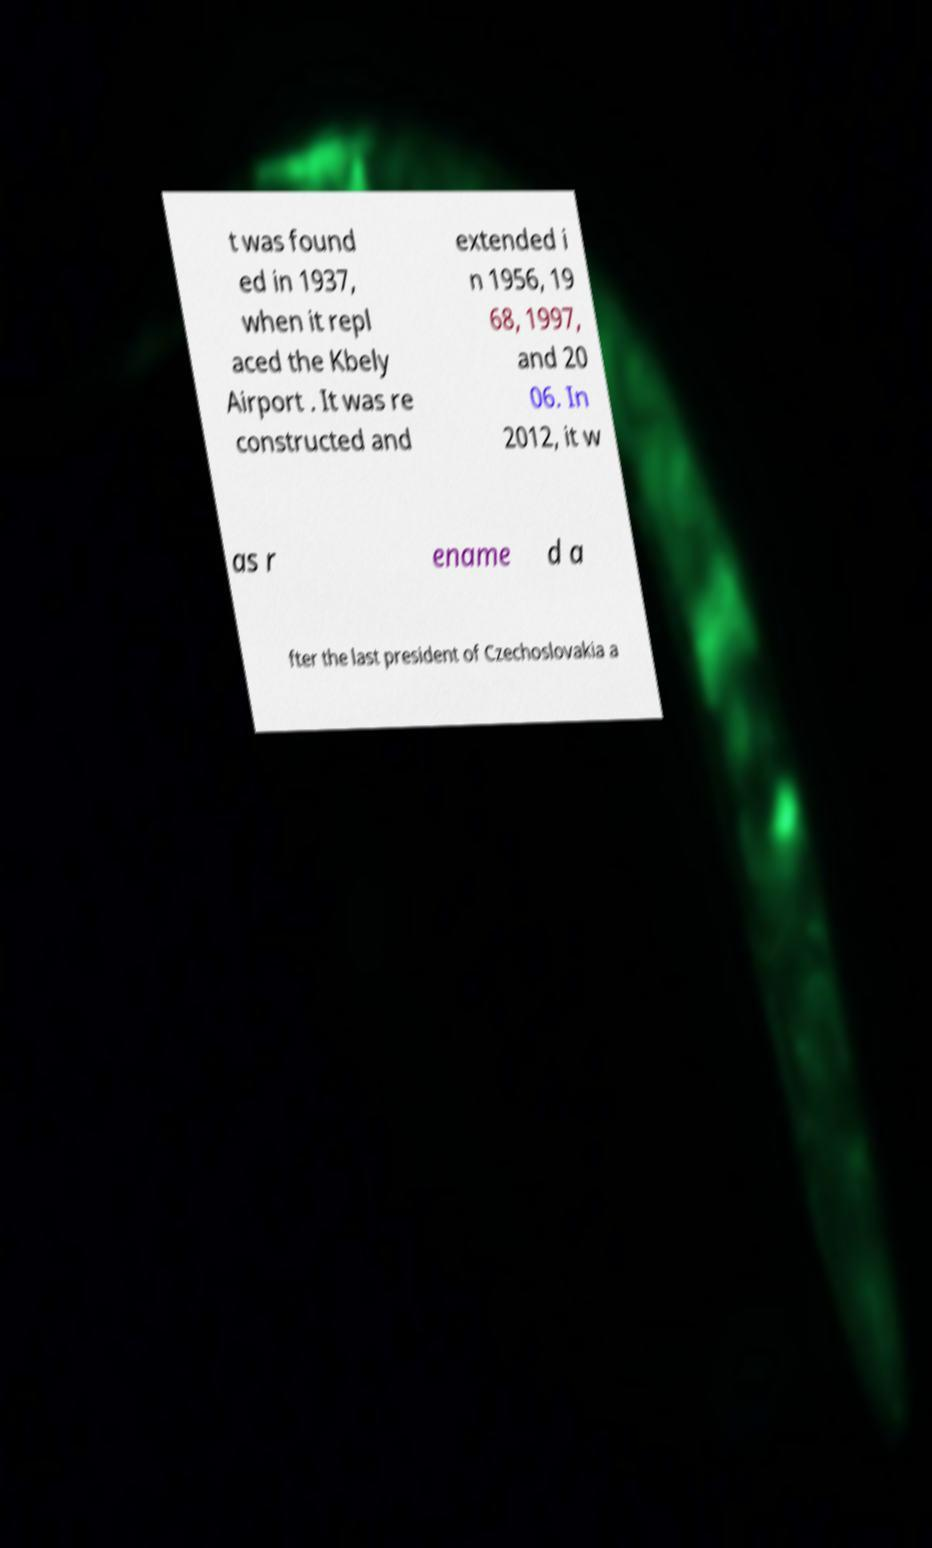Could you assist in decoding the text presented in this image and type it out clearly? t was found ed in 1937, when it repl aced the Kbely Airport . It was re constructed and extended i n 1956, 19 68, 1997, and 20 06. In 2012, it w as r ename d a fter the last president of Czechoslovakia a 